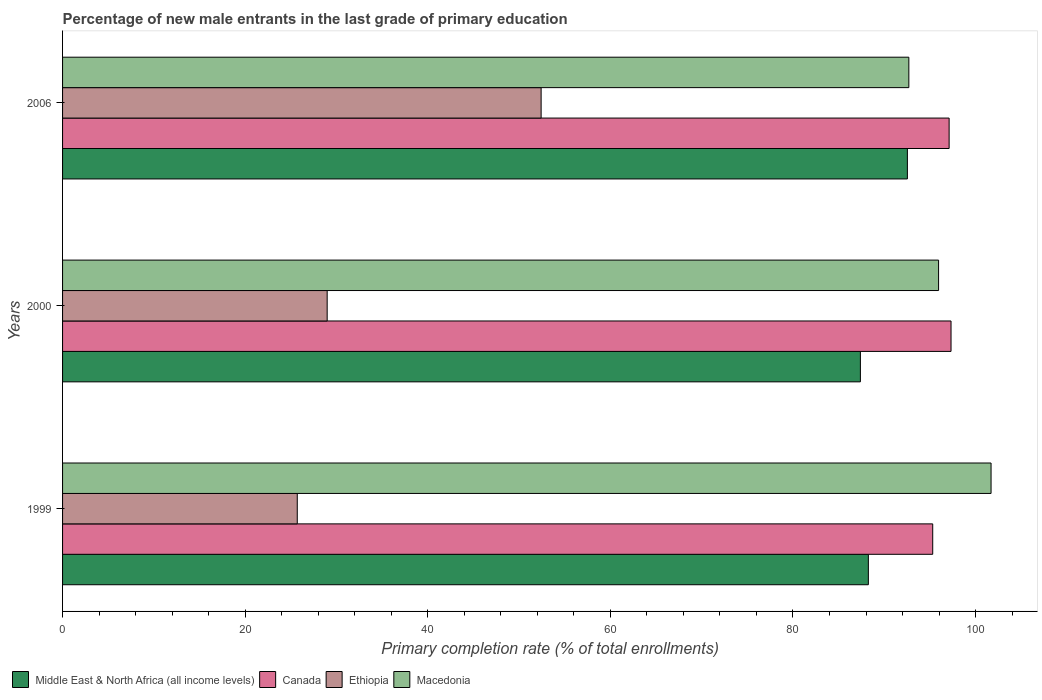How many groups of bars are there?
Provide a succinct answer. 3. Are the number of bars on each tick of the Y-axis equal?
Your answer should be compact. Yes. How many bars are there on the 2nd tick from the bottom?
Provide a succinct answer. 4. What is the label of the 1st group of bars from the top?
Provide a short and direct response. 2006. What is the percentage of new male entrants in Ethiopia in 1999?
Provide a short and direct response. 25.71. Across all years, what is the maximum percentage of new male entrants in Middle East & North Africa (all income levels)?
Your answer should be compact. 92.53. Across all years, what is the minimum percentage of new male entrants in Macedonia?
Your answer should be compact. 92.69. What is the total percentage of new male entrants in Middle East & North Africa (all income levels) in the graph?
Keep it short and to the point. 268.18. What is the difference between the percentage of new male entrants in Macedonia in 2000 and that in 2006?
Offer a terse response. 3.26. What is the difference between the percentage of new male entrants in Macedonia in 2006 and the percentage of new male entrants in Canada in 1999?
Offer a very short reply. -2.61. What is the average percentage of new male entrants in Macedonia per year?
Offer a very short reply. 96.78. In the year 2006, what is the difference between the percentage of new male entrants in Canada and percentage of new male entrants in Middle East & North Africa (all income levels)?
Offer a very short reply. 4.57. In how many years, is the percentage of new male entrants in Ethiopia greater than 32 %?
Your answer should be compact. 1. What is the ratio of the percentage of new male entrants in Middle East & North Africa (all income levels) in 2000 to that in 2006?
Ensure brevity in your answer.  0.94. What is the difference between the highest and the second highest percentage of new male entrants in Ethiopia?
Your answer should be compact. 23.43. What is the difference between the highest and the lowest percentage of new male entrants in Macedonia?
Your response must be concise. 9.01. Is the sum of the percentage of new male entrants in Ethiopia in 2000 and 2006 greater than the maximum percentage of new male entrants in Macedonia across all years?
Make the answer very short. No. Is it the case that in every year, the sum of the percentage of new male entrants in Middle East & North Africa (all income levels) and percentage of new male entrants in Macedonia is greater than the sum of percentage of new male entrants in Canada and percentage of new male entrants in Ethiopia?
Provide a short and direct response. Yes. What does the 4th bar from the top in 2006 represents?
Your answer should be very brief. Middle East & North Africa (all income levels). What does the 2nd bar from the bottom in 2000 represents?
Make the answer very short. Canada. How many bars are there?
Give a very brief answer. 12. Are all the bars in the graph horizontal?
Offer a very short reply. Yes. How many years are there in the graph?
Ensure brevity in your answer.  3. What is the difference between two consecutive major ticks on the X-axis?
Provide a succinct answer. 20. Does the graph contain grids?
Ensure brevity in your answer.  No. How many legend labels are there?
Provide a short and direct response. 4. What is the title of the graph?
Your response must be concise. Percentage of new male entrants in the last grade of primary education. Does "Croatia" appear as one of the legend labels in the graph?
Provide a short and direct response. No. What is the label or title of the X-axis?
Provide a succinct answer. Primary completion rate (% of total enrollments). What is the Primary completion rate (% of total enrollments) of Middle East & North Africa (all income levels) in 1999?
Provide a succinct answer. 88.26. What is the Primary completion rate (% of total enrollments) in Canada in 1999?
Give a very brief answer. 95.31. What is the Primary completion rate (% of total enrollments) in Ethiopia in 1999?
Make the answer very short. 25.71. What is the Primary completion rate (% of total enrollments) in Macedonia in 1999?
Provide a succinct answer. 101.7. What is the Primary completion rate (% of total enrollments) in Middle East & North Africa (all income levels) in 2000?
Your response must be concise. 87.39. What is the Primary completion rate (% of total enrollments) in Canada in 2000?
Provide a succinct answer. 97.31. What is the Primary completion rate (% of total enrollments) of Ethiopia in 2000?
Provide a succinct answer. 28.98. What is the Primary completion rate (% of total enrollments) of Macedonia in 2000?
Keep it short and to the point. 95.95. What is the Primary completion rate (% of total enrollments) of Middle East & North Africa (all income levels) in 2006?
Keep it short and to the point. 92.53. What is the Primary completion rate (% of total enrollments) of Canada in 2006?
Give a very brief answer. 97.11. What is the Primary completion rate (% of total enrollments) of Ethiopia in 2006?
Provide a succinct answer. 52.42. What is the Primary completion rate (% of total enrollments) of Macedonia in 2006?
Provide a succinct answer. 92.69. Across all years, what is the maximum Primary completion rate (% of total enrollments) in Middle East & North Africa (all income levels)?
Your answer should be compact. 92.53. Across all years, what is the maximum Primary completion rate (% of total enrollments) in Canada?
Your response must be concise. 97.31. Across all years, what is the maximum Primary completion rate (% of total enrollments) of Ethiopia?
Offer a terse response. 52.42. Across all years, what is the maximum Primary completion rate (% of total enrollments) of Macedonia?
Your response must be concise. 101.7. Across all years, what is the minimum Primary completion rate (% of total enrollments) in Middle East & North Africa (all income levels)?
Provide a succinct answer. 87.39. Across all years, what is the minimum Primary completion rate (% of total enrollments) in Canada?
Your answer should be very brief. 95.31. Across all years, what is the minimum Primary completion rate (% of total enrollments) of Ethiopia?
Your response must be concise. 25.71. Across all years, what is the minimum Primary completion rate (% of total enrollments) in Macedonia?
Offer a terse response. 92.69. What is the total Primary completion rate (% of total enrollments) in Middle East & North Africa (all income levels) in the graph?
Offer a very short reply. 268.18. What is the total Primary completion rate (% of total enrollments) in Canada in the graph?
Offer a terse response. 289.73. What is the total Primary completion rate (% of total enrollments) in Ethiopia in the graph?
Give a very brief answer. 107.11. What is the total Primary completion rate (% of total enrollments) of Macedonia in the graph?
Your response must be concise. 290.34. What is the difference between the Primary completion rate (% of total enrollments) in Middle East & North Africa (all income levels) in 1999 and that in 2000?
Offer a very short reply. 0.87. What is the difference between the Primary completion rate (% of total enrollments) of Canada in 1999 and that in 2000?
Your answer should be compact. -2.01. What is the difference between the Primary completion rate (% of total enrollments) of Ethiopia in 1999 and that in 2000?
Provide a short and direct response. -3.28. What is the difference between the Primary completion rate (% of total enrollments) of Macedonia in 1999 and that in 2000?
Ensure brevity in your answer.  5.75. What is the difference between the Primary completion rate (% of total enrollments) of Middle East & North Africa (all income levels) in 1999 and that in 2006?
Ensure brevity in your answer.  -4.27. What is the difference between the Primary completion rate (% of total enrollments) in Canada in 1999 and that in 2006?
Your answer should be compact. -1.8. What is the difference between the Primary completion rate (% of total enrollments) in Ethiopia in 1999 and that in 2006?
Your response must be concise. -26.71. What is the difference between the Primary completion rate (% of total enrollments) of Macedonia in 1999 and that in 2006?
Keep it short and to the point. 9.01. What is the difference between the Primary completion rate (% of total enrollments) in Middle East & North Africa (all income levels) in 2000 and that in 2006?
Make the answer very short. -5.15. What is the difference between the Primary completion rate (% of total enrollments) of Canada in 2000 and that in 2006?
Keep it short and to the point. 0.21. What is the difference between the Primary completion rate (% of total enrollments) of Ethiopia in 2000 and that in 2006?
Provide a short and direct response. -23.43. What is the difference between the Primary completion rate (% of total enrollments) in Macedonia in 2000 and that in 2006?
Give a very brief answer. 3.26. What is the difference between the Primary completion rate (% of total enrollments) of Middle East & North Africa (all income levels) in 1999 and the Primary completion rate (% of total enrollments) of Canada in 2000?
Make the answer very short. -9.05. What is the difference between the Primary completion rate (% of total enrollments) in Middle East & North Africa (all income levels) in 1999 and the Primary completion rate (% of total enrollments) in Ethiopia in 2000?
Your answer should be very brief. 59.28. What is the difference between the Primary completion rate (% of total enrollments) of Middle East & North Africa (all income levels) in 1999 and the Primary completion rate (% of total enrollments) of Macedonia in 2000?
Your response must be concise. -7.69. What is the difference between the Primary completion rate (% of total enrollments) of Canada in 1999 and the Primary completion rate (% of total enrollments) of Ethiopia in 2000?
Your response must be concise. 66.33. What is the difference between the Primary completion rate (% of total enrollments) in Canada in 1999 and the Primary completion rate (% of total enrollments) in Macedonia in 2000?
Keep it short and to the point. -0.64. What is the difference between the Primary completion rate (% of total enrollments) in Ethiopia in 1999 and the Primary completion rate (% of total enrollments) in Macedonia in 2000?
Your answer should be compact. -70.24. What is the difference between the Primary completion rate (% of total enrollments) of Middle East & North Africa (all income levels) in 1999 and the Primary completion rate (% of total enrollments) of Canada in 2006?
Make the answer very short. -8.85. What is the difference between the Primary completion rate (% of total enrollments) in Middle East & North Africa (all income levels) in 1999 and the Primary completion rate (% of total enrollments) in Ethiopia in 2006?
Provide a succinct answer. 35.84. What is the difference between the Primary completion rate (% of total enrollments) of Middle East & North Africa (all income levels) in 1999 and the Primary completion rate (% of total enrollments) of Macedonia in 2006?
Provide a succinct answer. -4.43. What is the difference between the Primary completion rate (% of total enrollments) in Canada in 1999 and the Primary completion rate (% of total enrollments) in Ethiopia in 2006?
Make the answer very short. 42.89. What is the difference between the Primary completion rate (% of total enrollments) of Canada in 1999 and the Primary completion rate (% of total enrollments) of Macedonia in 2006?
Your answer should be compact. 2.61. What is the difference between the Primary completion rate (% of total enrollments) in Ethiopia in 1999 and the Primary completion rate (% of total enrollments) in Macedonia in 2006?
Offer a terse response. -66.99. What is the difference between the Primary completion rate (% of total enrollments) of Middle East & North Africa (all income levels) in 2000 and the Primary completion rate (% of total enrollments) of Canada in 2006?
Provide a succinct answer. -9.72. What is the difference between the Primary completion rate (% of total enrollments) of Middle East & North Africa (all income levels) in 2000 and the Primary completion rate (% of total enrollments) of Ethiopia in 2006?
Offer a terse response. 34.97. What is the difference between the Primary completion rate (% of total enrollments) in Middle East & North Africa (all income levels) in 2000 and the Primary completion rate (% of total enrollments) in Macedonia in 2006?
Offer a very short reply. -5.31. What is the difference between the Primary completion rate (% of total enrollments) of Canada in 2000 and the Primary completion rate (% of total enrollments) of Ethiopia in 2006?
Make the answer very short. 44.9. What is the difference between the Primary completion rate (% of total enrollments) in Canada in 2000 and the Primary completion rate (% of total enrollments) in Macedonia in 2006?
Provide a succinct answer. 4.62. What is the difference between the Primary completion rate (% of total enrollments) in Ethiopia in 2000 and the Primary completion rate (% of total enrollments) in Macedonia in 2006?
Make the answer very short. -63.71. What is the average Primary completion rate (% of total enrollments) in Middle East & North Africa (all income levels) per year?
Ensure brevity in your answer.  89.39. What is the average Primary completion rate (% of total enrollments) in Canada per year?
Your answer should be compact. 96.58. What is the average Primary completion rate (% of total enrollments) of Ethiopia per year?
Make the answer very short. 35.7. What is the average Primary completion rate (% of total enrollments) in Macedonia per year?
Offer a very short reply. 96.78. In the year 1999, what is the difference between the Primary completion rate (% of total enrollments) in Middle East & North Africa (all income levels) and Primary completion rate (% of total enrollments) in Canada?
Your response must be concise. -7.05. In the year 1999, what is the difference between the Primary completion rate (% of total enrollments) of Middle East & North Africa (all income levels) and Primary completion rate (% of total enrollments) of Ethiopia?
Your answer should be very brief. 62.55. In the year 1999, what is the difference between the Primary completion rate (% of total enrollments) of Middle East & North Africa (all income levels) and Primary completion rate (% of total enrollments) of Macedonia?
Provide a short and direct response. -13.44. In the year 1999, what is the difference between the Primary completion rate (% of total enrollments) in Canada and Primary completion rate (% of total enrollments) in Ethiopia?
Keep it short and to the point. 69.6. In the year 1999, what is the difference between the Primary completion rate (% of total enrollments) of Canada and Primary completion rate (% of total enrollments) of Macedonia?
Provide a short and direct response. -6.39. In the year 1999, what is the difference between the Primary completion rate (% of total enrollments) of Ethiopia and Primary completion rate (% of total enrollments) of Macedonia?
Your answer should be compact. -75.99. In the year 2000, what is the difference between the Primary completion rate (% of total enrollments) in Middle East & North Africa (all income levels) and Primary completion rate (% of total enrollments) in Canada?
Keep it short and to the point. -9.93. In the year 2000, what is the difference between the Primary completion rate (% of total enrollments) of Middle East & North Africa (all income levels) and Primary completion rate (% of total enrollments) of Ethiopia?
Ensure brevity in your answer.  58.4. In the year 2000, what is the difference between the Primary completion rate (% of total enrollments) of Middle East & North Africa (all income levels) and Primary completion rate (% of total enrollments) of Macedonia?
Ensure brevity in your answer.  -8.56. In the year 2000, what is the difference between the Primary completion rate (% of total enrollments) in Canada and Primary completion rate (% of total enrollments) in Ethiopia?
Your response must be concise. 68.33. In the year 2000, what is the difference between the Primary completion rate (% of total enrollments) of Canada and Primary completion rate (% of total enrollments) of Macedonia?
Your answer should be very brief. 1.36. In the year 2000, what is the difference between the Primary completion rate (% of total enrollments) of Ethiopia and Primary completion rate (% of total enrollments) of Macedonia?
Offer a terse response. -66.97. In the year 2006, what is the difference between the Primary completion rate (% of total enrollments) of Middle East & North Africa (all income levels) and Primary completion rate (% of total enrollments) of Canada?
Offer a terse response. -4.57. In the year 2006, what is the difference between the Primary completion rate (% of total enrollments) of Middle East & North Africa (all income levels) and Primary completion rate (% of total enrollments) of Ethiopia?
Provide a short and direct response. 40.12. In the year 2006, what is the difference between the Primary completion rate (% of total enrollments) of Middle East & North Africa (all income levels) and Primary completion rate (% of total enrollments) of Macedonia?
Provide a succinct answer. -0.16. In the year 2006, what is the difference between the Primary completion rate (% of total enrollments) in Canada and Primary completion rate (% of total enrollments) in Ethiopia?
Your answer should be compact. 44.69. In the year 2006, what is the difference between the Primary completion rate (% of total enrollments) of Canada and Primary completion rate (% of total enrollments) of Macedonia?
Offer a very short reply. 4.41. In the year 2006, what is the difference between the Primary completion rate (% of total enrollments) in Ethiopia and Primary completion rate (% of total enrollments) in Macedonia?
Ensure brevity in your answer.  -40.28. What is the ratio of the Primary completion rate (% of total enrollments) of Canada in 1999 to that in 2000?
Offer a terse response. 0.98. What is the ratio of the Primary completion rate (% of total enrollments) in Ethiopia in 1999 to that in 2000?
Offer a terse response. 0.89. What is the ratio of the Primary completion rate (% of total enrollments) in Macedonia in 1999 to that in 2000?
Ensure brevity in your answer.  1.06. What is the ratio of the Primary completion rate (% of total enrollments) in Middle East & North Africa (all income levels) in 1999 to that in 2006?
Your response must be concise. 0.95. What is the ratio of the Primary completion rate (% of total enrollments) in Canada in 1999 to that in 2006?
Offer a very short reply. 0.98. What is the ratio of the Primary completion rate (% of total enrollments) in Ethiopia in 1999 to that in 2006?
Offer a terse response. 0.49. What is the ratio of the Primary completion rate (% of total enrollments) of Macedonia in 1999 to that in 2006?
Your answer should be very brief. 1.1. What is the ratio of the Primary completion rate (% of total enrollments) of Ethiopia in 2000 to that in 2006?
Keep it short and to the point. 0.55. What is the ratio of the Primary completion rate (% of total enrollments) of Macedonia in 2000 to that in 2006?
Make the answer very short. 1.04. What is the difference between the highest and the second highest Primary completion rate (% of total enrollments) in Middle East & North Africa (all income levels)?
Offer a very short reply. 4.27. What is the difference between the highest and the second highest Primary completion rate (% of total enrollments) of Canada?
Keep it short and to the point. 0.21. What is the difference between the highest and the second highest Primary completion rate (% of total enrollments) of Ethiopia?
Provide a succinct answer. 23.43. What is the difference between the highest and the second highest Primary completion rate (% of total enrollments) in Macedonia?
Provide a succinct answer. 5.75. What is the difference between the highest and the lowest Primary completion rate (% of total enrollments) in Middle East & North Africa (all income levels)?
Ensure brevity in your answer.  5.15. What is the difference between the highest and the lowest Primary completion rate (% of total enrollments) in Canada?
Your response must be concise. 2.01. What is the difference between the highest and the lowest Primary completion rate (% of total enrollments) in Ethiopia?
Keep it short and to the point. 26.71. What is the difference between the highest and the lowest Primary completion rate (% of total enrollments) of Macedonia?
Provide a succinct answer. 9.01. 